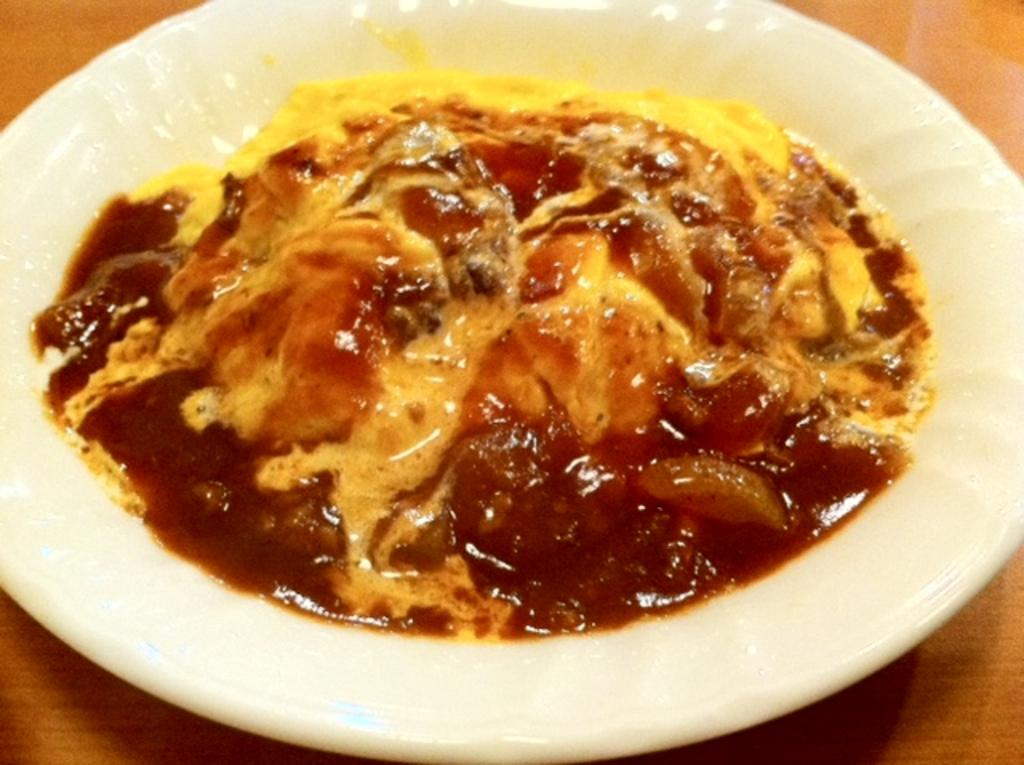What is present on the plate in the image? The plate contains food items. Where is the plate located in the image? The plate is placed on a surface. What type of fairies can be seen flying around the plate in the image? There are no fairies present in the image; it only contains a plate with food items. 